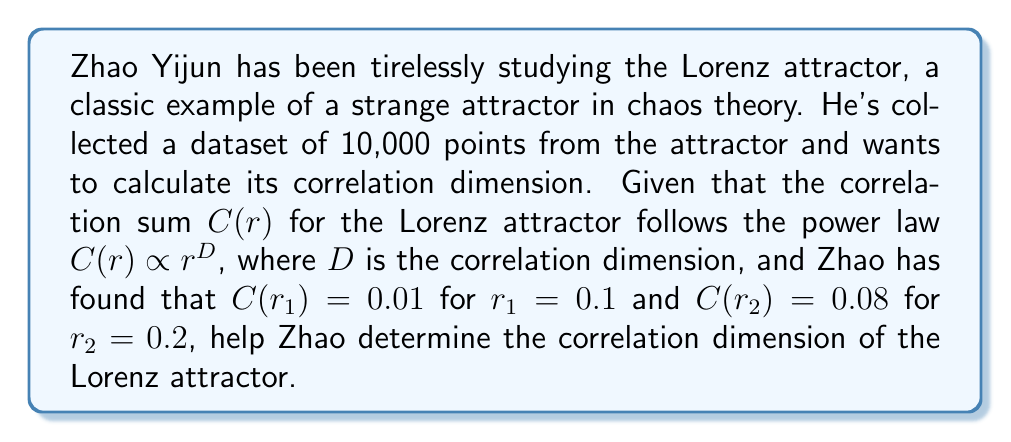Could you help me with this problem? Let's approach this step-by-step:

1) The correlation sum follows the power law:
   $$C(r) \propto r^D$$

2) This means we can write:
   $$C(r) = kr^D$$
   where $k$ is some constant.

3) We have two data points:
   $$C(r_1) = 0.01, r_1 = 0.1$$
   $$C(r_2) = 0.08, r_2 = 0.2$$

4) We can write two equations:
   $$0.01 = k(0.1)^D$$
   $$0.08 = k(0.2)^D$$

5) Dividing the second equation by the first:
   $$\frac{0.08}{0.01} = \frac{k(0.2)^D}{k(0.1)^D}$$

6) The $k$ cancels out:
   $$8 = 2^D$$

7) Taking the logarithm of both sides:
   $$\log_2 8 = D$$

8) We know that $\log_2 8 = 3$, so:
   $$D = 3$$

Therefore, the correlation dimension of the Lorenz attractor based on Zhao's data is 3.
Answer: $3$ 